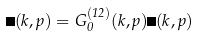Convert formula to latex. <formula><loc_0><loc_0><loc_500><loc_500>\Phi ( k , p ) = G ^ { ( 1 2 ) } _ { 0 } ( k , p ) \Gamma ( k , p )</formula> 